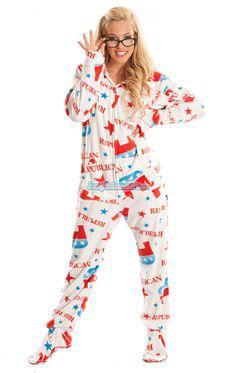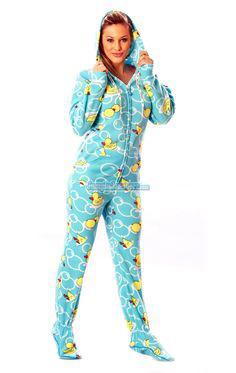The first image is the image on the left, the second image is the image on the right. For the images displayed, is the sentence "Both images must be females." factually correct? Answer yes or no. Yes. The first image is the image on the left, the second image is the image on the right. Analyze the images presented: Is the assertion "Two women are wearing footed pajamas, one of them with the attached hood pulled over her head." valid? Answer yes or no. Yes. 